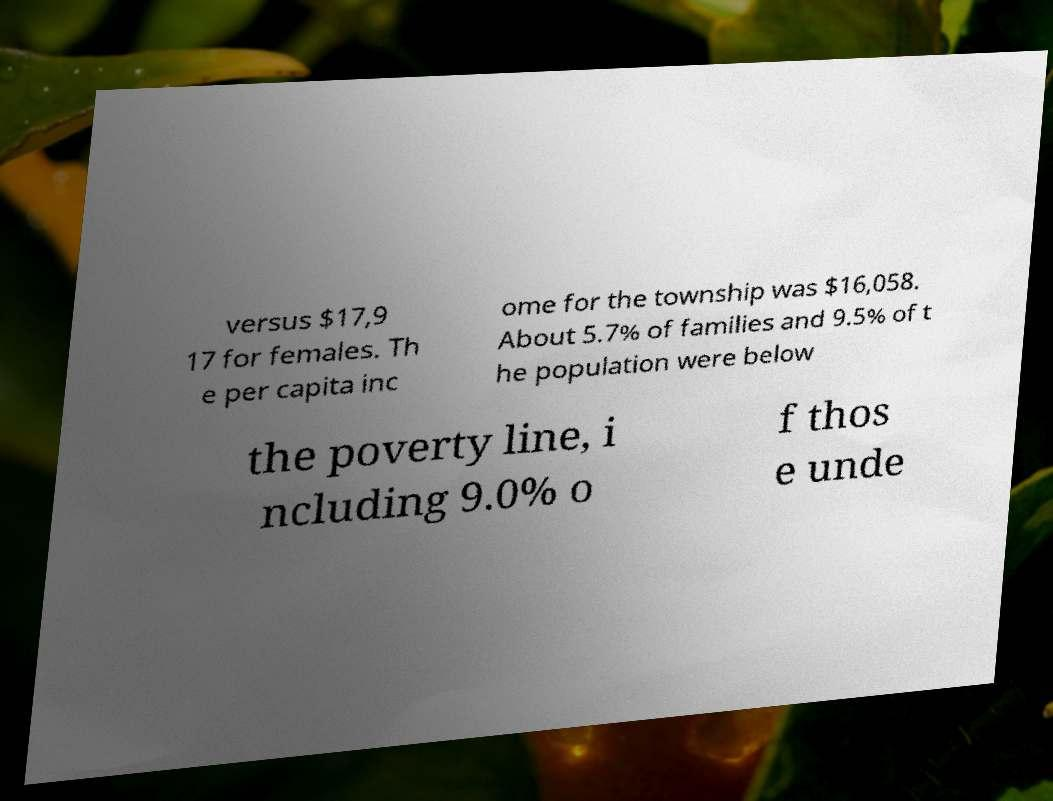Could you extract and type out the text from this image? versus $17,9 17 for females. Th e per capita inc ome for the township was $16,058. About 5.7% of families and 9.5% of t he population were below the poverty line, i ncluding 9.0% o f thos e unde 